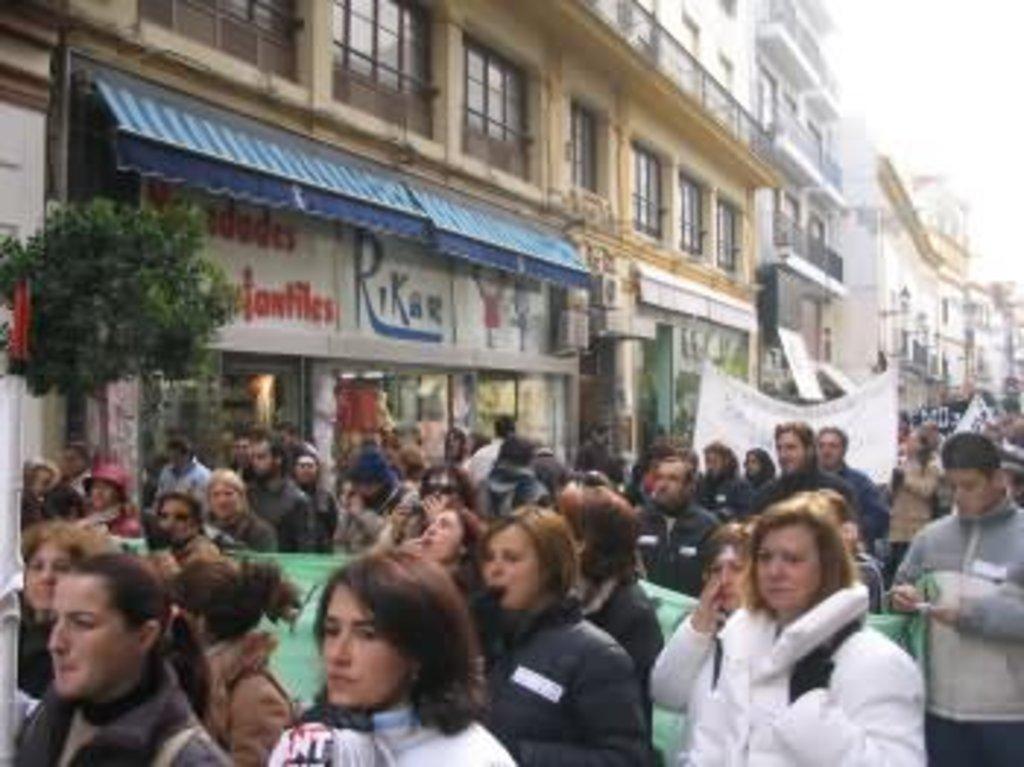Describe this image in one or two sentences. In this image I can see few buildings, windows, trees, stores and the group of people are walking. Few people are holding banners and the sky is in white color. 